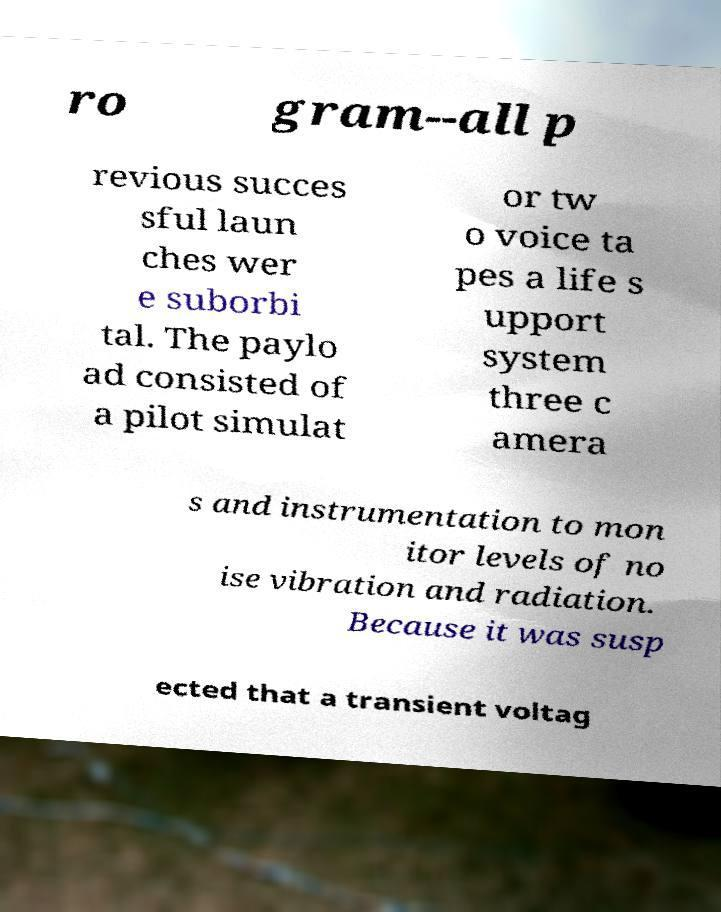Could you assist in decoding the text presented in this image and type it out clearly? ro gram--all p revious succes sful laun ches wer e suborbi tal. The paylo ad consisted of a pilot simulat or tw o voice ta pes a life s upport system three c amera s and instrumentation to mon itor levels of no ise vibration and radiation. Because it was susp ected that a transient voltag 